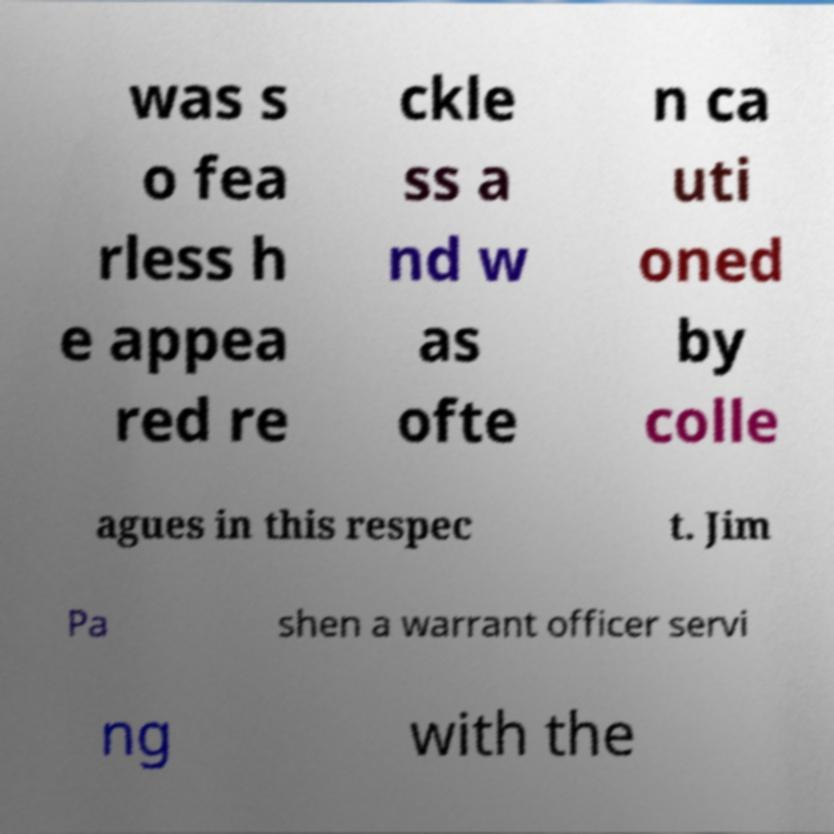Could you extract and type out the text from this image? was s o fea rless h e appea red re ckle ss a nd w as ofte n ca uti oned by colle agues in this respec t. Jim Pa shen a warrant officer servi ng with the 